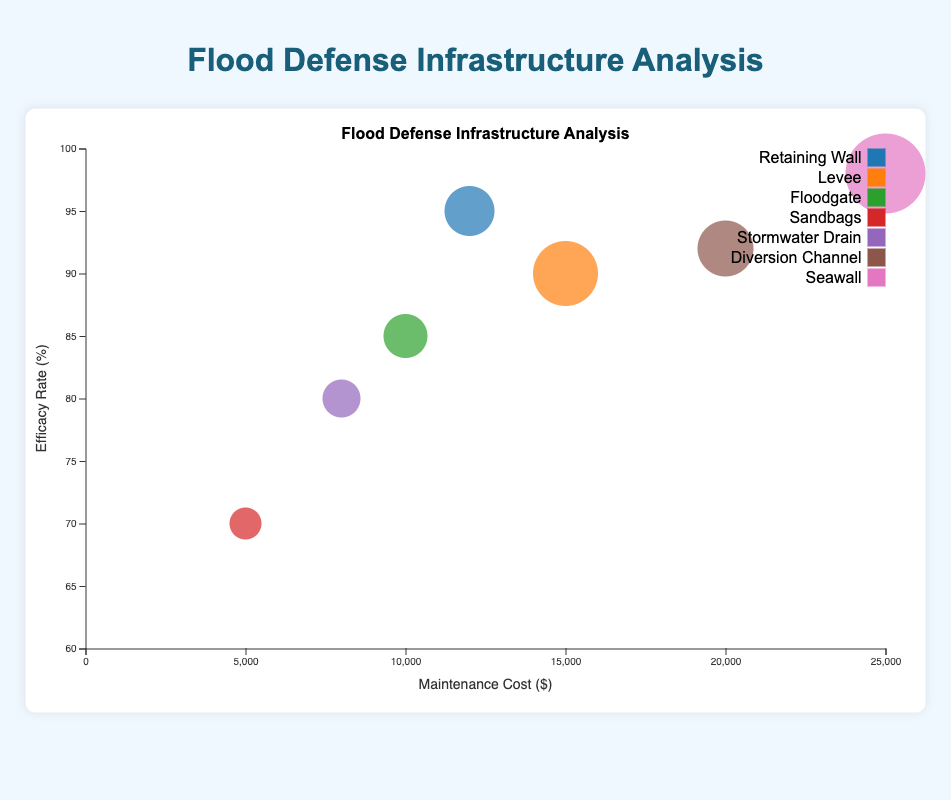What's the title of the chart? The title is displayed at the top of the figure. It reads "Flood Defense Infrastructure Analysis".
Answer: Flood Defense Infrastructure Analysis What are the axes labeled as? The label on the horizontal axis is "Maintenance Cost ($)", and the label on the vertical axis is "Efficacy Rate (%)".
Answer: Maintenance Cost ($) and Efficacy Rate (%) Which location has the highest maintenance cost? The bubble located furthest to the right on the horizontal axis represents the highest maintenance cost. According to the tooltip details, this is the Harbor with a cost of $25,000.
Answer: Harbor Which flood defense type has the highest efficacy rate? Looking at the bubble that is highest on the vertical axis, we find that the Seawall at the Harbor has the highest efficacy rate of 98%.
Answer: Seawall (Harbor) How many locations are there in total? There are seven bubbles in total, each representing a distinct location.
Answer: Seven Which location has the lowest efficacy rate? The bubble lowest on the vertical axis signifies the lowest efficacy rate, which corresponds to Sandbags at Eastside with a rate of 70%.
Answer: Eastside What is the average maintenance cost of all listed flood defenses? Add all maintenance costs and divide by the number of locations: (12000 + 15000 + 10000 + 5000 + 8000 + 20000 + 25000) / 7. This calculation results in an average of $13571.43.
Answer: $13571.43 Compare the efficacy rates of Downtown and Industrial Zone. Which one is higher? By examining their positions on the vertical axis, Downtown's Retaining Wall has an efficacy rate of 95%, and Industrial Zone's Diversion Channel has an efficacy rate of 92%. Thus, Downtown has a higher efficacy rate.
Answer: Downtown Which location has the highest average height of flood defenses? The largest bubble indicates the highest average height. The tooltip for the Harbor's Seawall shows an average height of 20 feet, which is the highest.
Answer: Harbor What is the difference in maintenance cost between the Riverside and Uptown locations? Subtract Uptown's maintenance cost from Riverside's: 15000 - 10000 = 5000. The difference is $5000.
Answer: $5000 